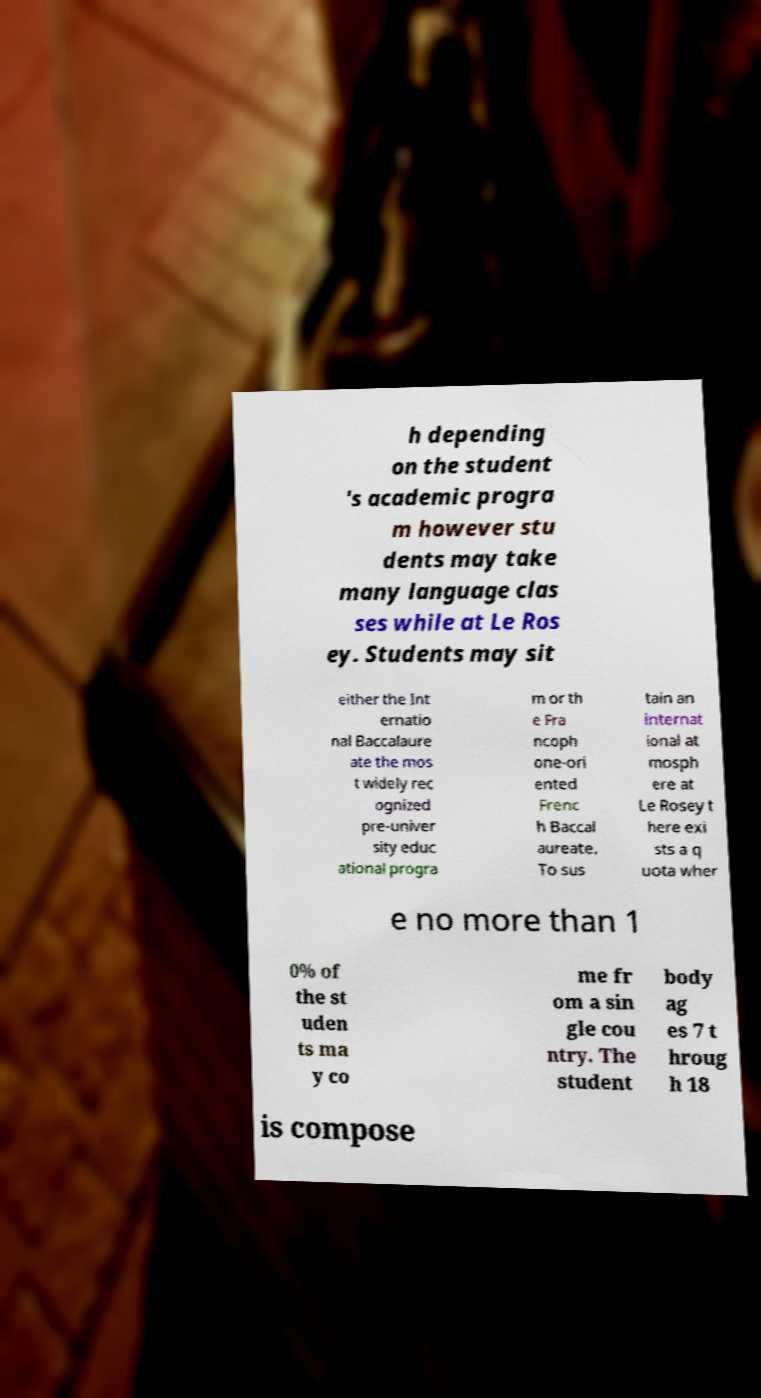I need the written content from this picture converted into text. Can you do that? h depending on the student 's academic progra m however stu dents may take many language clas ses while at Le Ros ey. Students may sit either the Int ernatio nal Baccalaure ate the mos t widely rec ognized pre-univer sity educ ational progra m or th e Fra ncoph one-ori ented Frenc h Baccal aureate. To sus tain an internat ional at mosph ere at Le Rosey t here exi sts a q uota wher e no more than 1 0% of the st uden ts ma y co me fr om a sin gle cou ntry. The student body ag es 7 t hroug h 18 is compose 